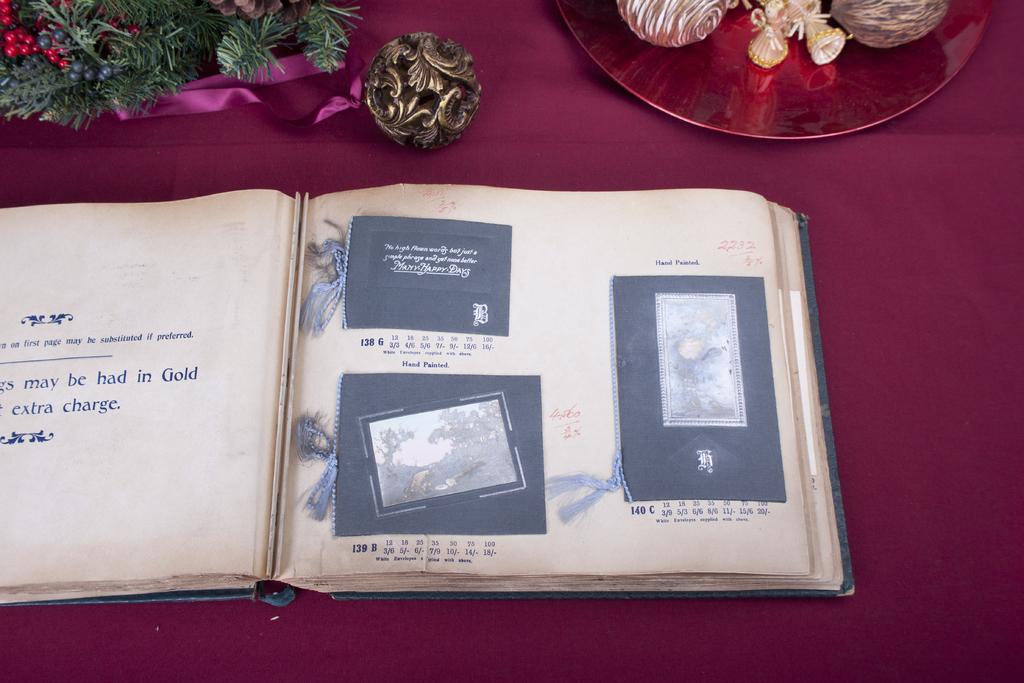What word follows extra?
Provide a short and direct response. Charge. 